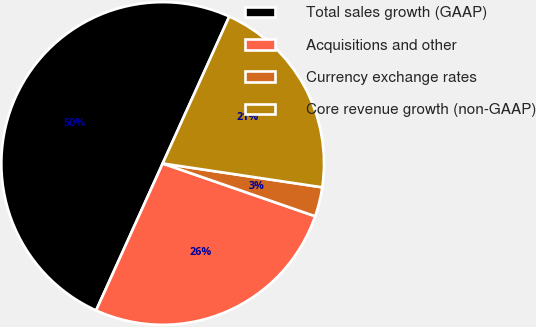<chart> <loc_0><loc_0><loc_500><loc_500><pie_chart><fcel>Total sales growth (GAAP)<fcel>Acquisitions and other<fcel>Currency exchange rates<fcel>Core revenue growth (non-GAAP)<nl><fcel>50.0%<fcel>26.47%<fcel>2.94%<fcel>20.59%<nl></chart> 